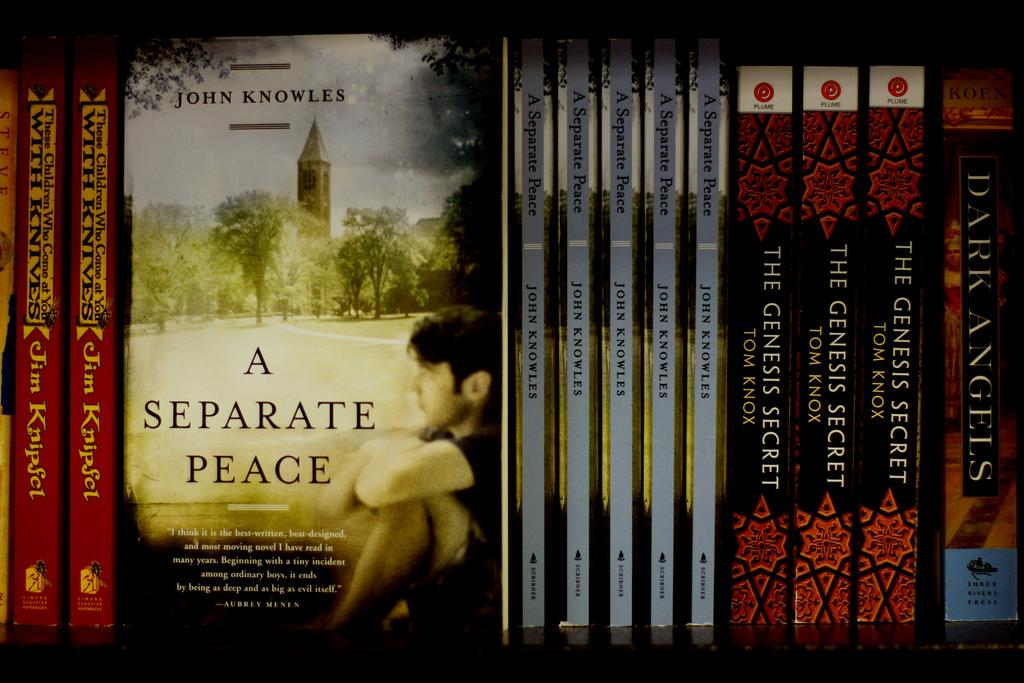<image>
Write a terse but informative summary of the picture. On the shelf are three books written by Tom Knox. 